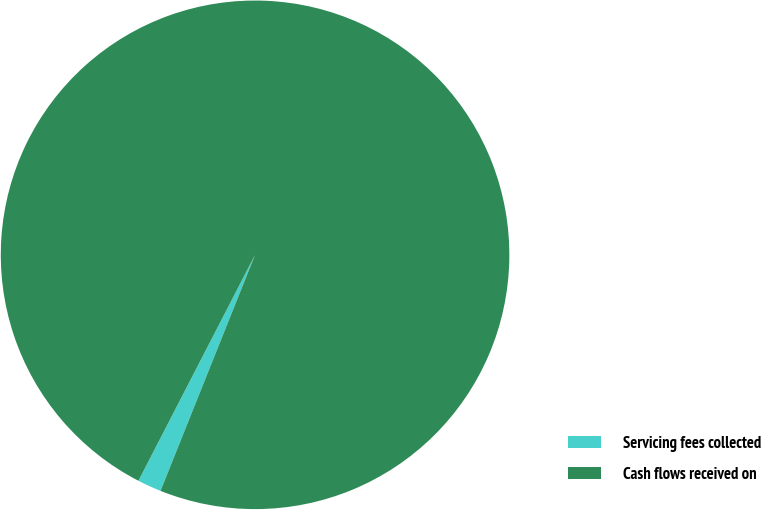<chart> <loc_0><loc_0><loc_500><loc_500><pie_chart><fcel>Servicing fees collected<fcel>Cash flows received on<nl><fcel>1.52%<fcel>98.48%<nl></chart> 